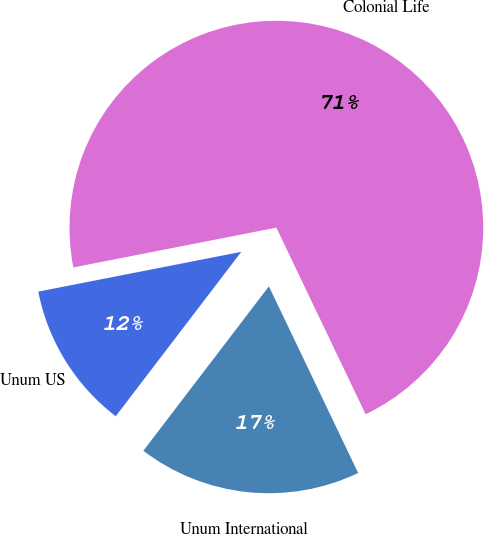Convert chart to OTSL. <chart><loc_0><loc_0><loc_500><loc_500><pie_chart><fcel>Unum US<fcel>Unum International<fcel>Colonial Life<nl><fcel>11.54%<fcel>17.48%<fcel>70.98%<nl></chart> 